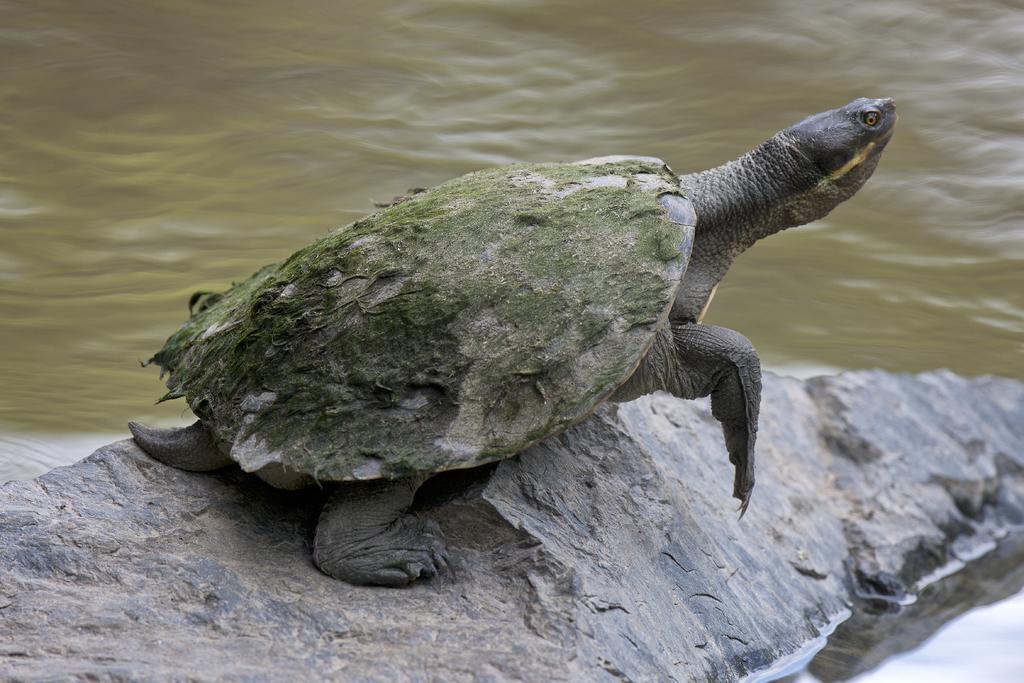How would you summarize this image in a sentence or two? In this image there is a tortoise. There is a stone. There is water. 